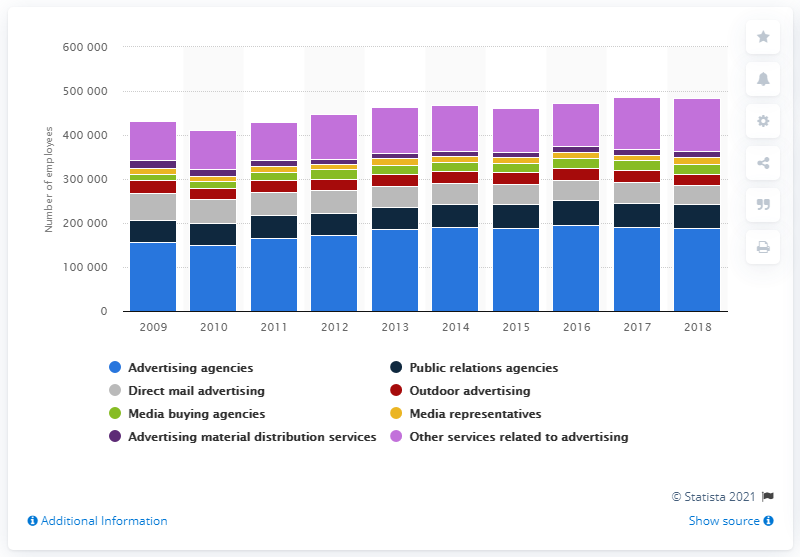Indicate a few pertinent items in this graphic. In 2018, there were approximately 187,908 people who were employed by advertising agencies in the United States. In the past two years, a total of 191,742 people worked for advertising agencies in the United States. 